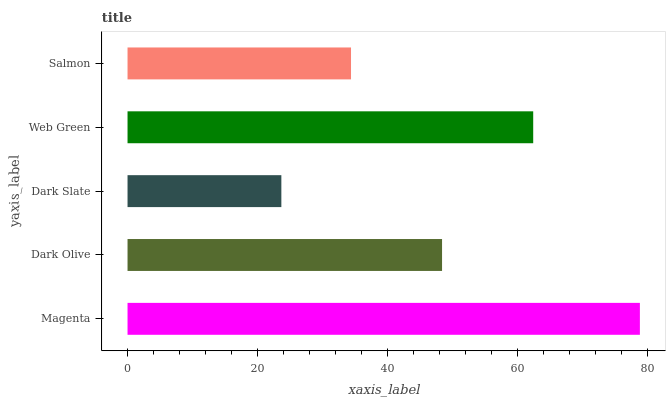Is Dark Slate the minimum?
Answer yes or no. Yes. Is Magenta the maximum?
Answer yes or no. Yes. Is Dark Olive the minimum?
Answer yes or no. No. Is Dark Olive the maximum?
Answer yes or no. No. Is Magenta greater than Dark Olive?
Answer yes or no. Yes. Is Dark Olive less than Magenta?
Answer yes or no. Yes. Is Dark Olive greater than Magenta?
Answer yes or no. No. Is Magenta less than Dark Olive?
Answer yes or no. No. Is Dark Olive the high median?
Answer yes or no. Yes. Is Dark Olive the low median?
Answer yes or no. Yes. Is Magenta the high median?
Answer yes or no. No. Is Salmon the low median?
Answer yes or no. No. 